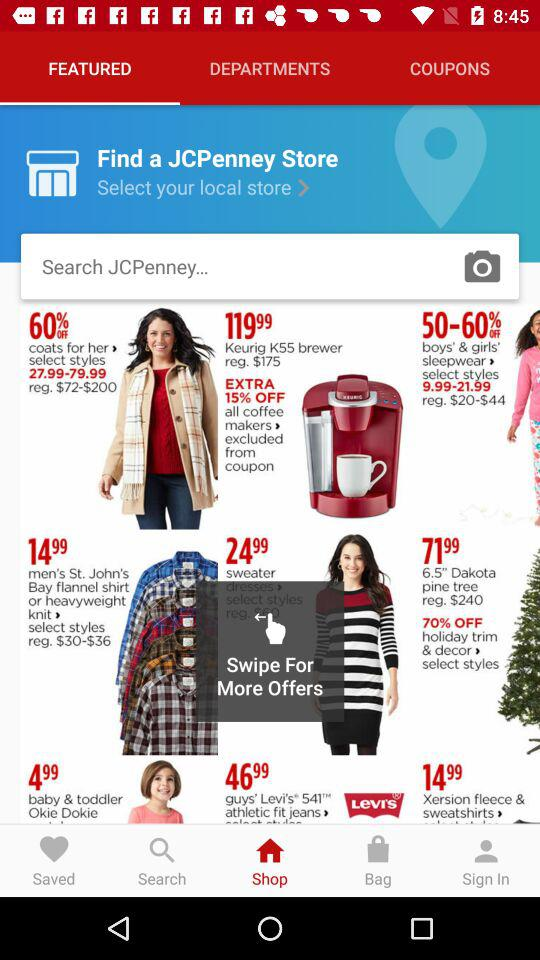How much of a discount is given on boys' and girls' sleepwear? The discount is 50–60% off. 